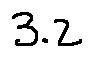<formula> <loc_0><loc_0><loc_500><loc_500>3 . 2</formula> 